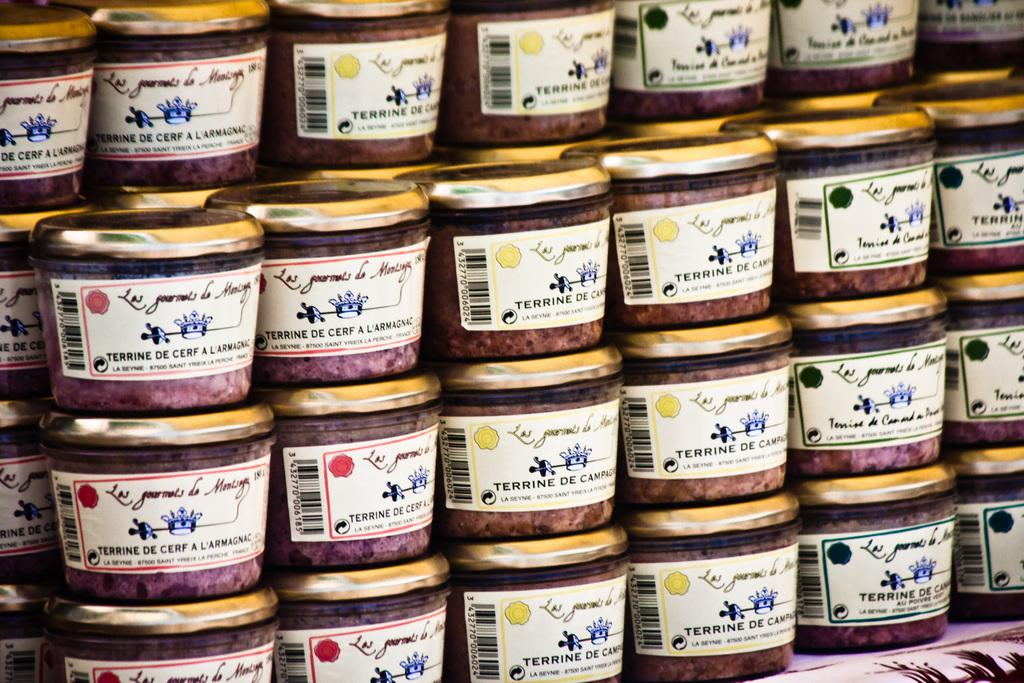<image>
Write a terse but informative summary of the picture. A stack of containers with the french language label, Terrine De Cerf L 